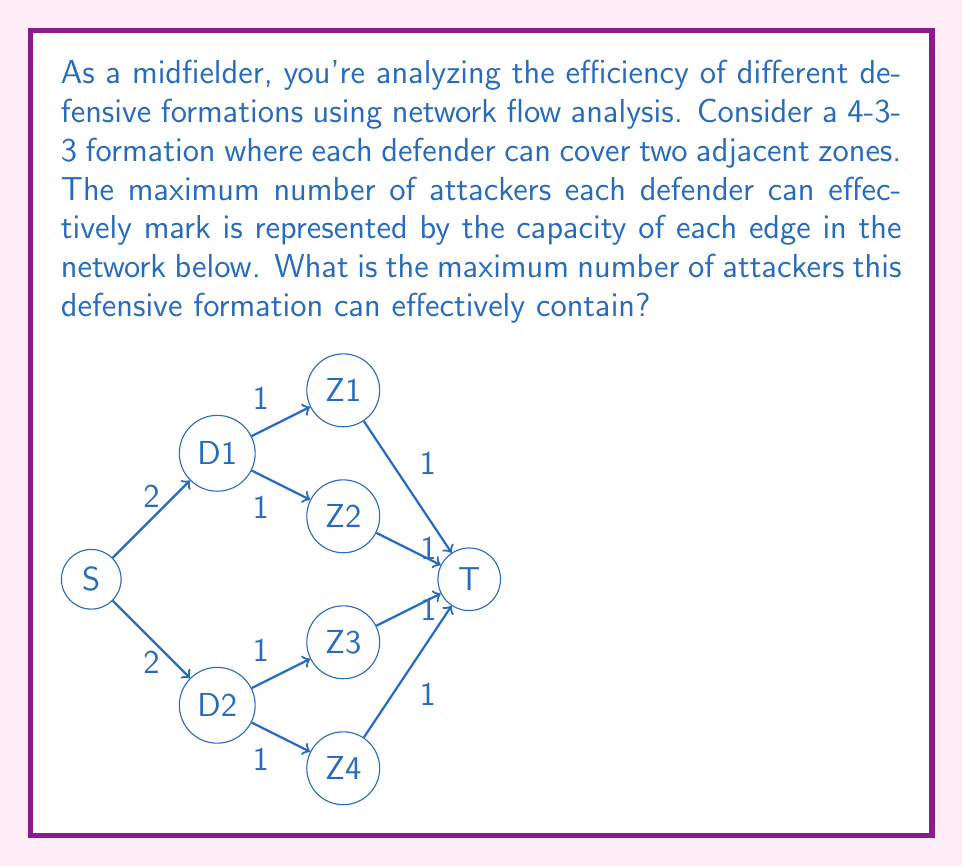Provide a solution to this math problem. To solve this problem, we'll use the max-flow min-cut theorem from network flow analysis. Here's a step-by-step approach:

1) Identify the source (S) and sink (T) in the network. S represents the starting point of the flow (attackers), and T represents the endpoint (successfully passing the defense).

2) Observe the network structure:
   - S connects to two defenders (D1 and D2) with capacity 2 each.
   - Each defender connects to two zones (Z1-Z4) with capacity 1 each.
   - Each zone connects to T with capacity 1.

3) To find the maximum flow, we need to find the minimum cut in the network. The minimum cut is the set of edges with the smallest total capacity that, if removed, would disconnect S from T.

4) Possible cuts:
   a) Cut the edges from S to D1 and D2: 2 + 2 = 4
   b) Cut the edges from defenders to zones: 1 + 1 + 1 + 1 = 4
   c) Cut the edges from zones to T: 1 + 1 + 1 + 1 = 4

5) The minimum cut has a capacity of 4, which occurs in all three cases above.

6) By the max-flow min-cut theorem, the maximum flow through the network equals the capacity of the minimum cut.

Therefore, the maximum number of attackers this defensive formation can effectively contain is 4.
Answer: 4 attackers 